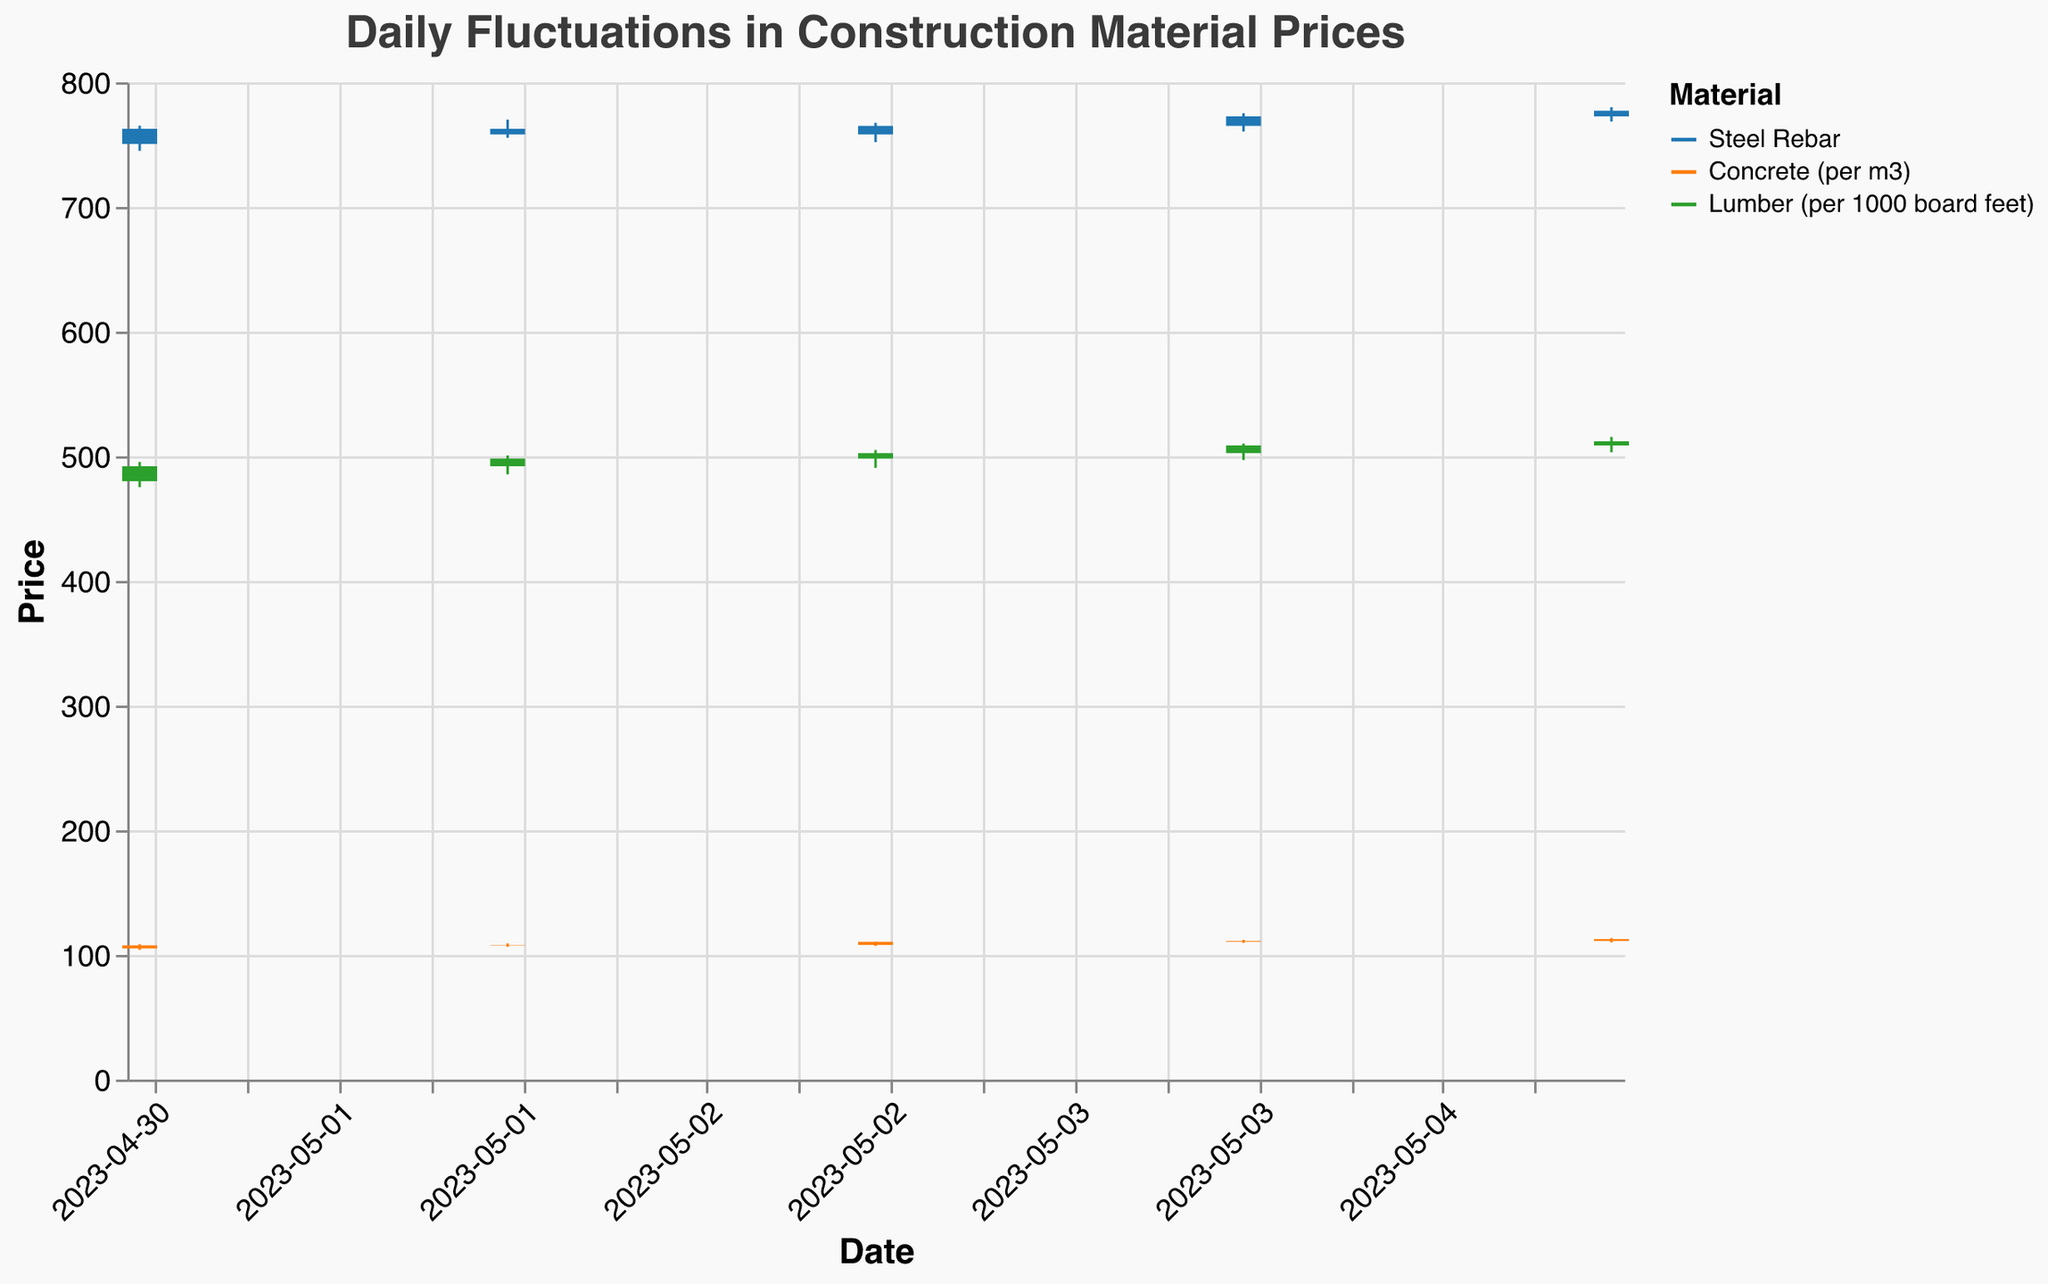what does the plot title indicate? The title of the plot is "Daily Fluctuations in Construction Material Prices," which indicates that the plot shows how the prices of different construction materials fluctuate on a daily basis.
Answer: Daily Fluctuations in Construction Material Prices how many types of materials are being compared? The color legend indicates three different colors, each representing a different construction material: Steel Rebar, Concrete (per m3), and Lumber (per 1000 board feet).
Answer: 3 on which date did Steel Rebar have the lowest price? Referring to the low points on the vertical rules for Steel Rebar, the lowest price was on May 1st, with a low of 745.00.
Answer: 2023-05-01 what was the opening price of Lumber on May 4th? By referencing the data point for Lumber on May 4th, we find that the opening price was 502.50.
Answer: 502.50 which material showed the highest closing price on May 3rd? Among the closing prices on May 3rd, Concrete (per m3) had the highest closing price of 110.50.
Answer: Concrete (per m3) what's the range of Steel Rebar prices on May 5th? For May 5th, Steel Rebar's high and low prices were 780.00 and 768.50 respectively. The range is 780.00 - 768.50 = 11.50.
Answer: 11.50 did Concrete's price increase or decrease from May 4th to May 5th? Concrete's closing price on May 4th was 111.25, and on May 5th it was 112.75. Since 112.75 > 111.25, the price increased.
Answer: increased compared to Lumber, how much did Steel Rebar's closing price increase on May 3rd? Steel Rebar's closing price on May 3rd was 765.00 while Lumber's closing price was 502.50. The increase is 765.00 - 502.50 = 262.50.
Answer: 262.50 which material had the most stable prices throughout the observed period? By considering the data range and fluctuations, Concrete had the smallest variations in its prices every day, making it the most stable material.
Answer: Concrete (per m3) based on the last recorded date, which material closed at a higher price, Steel Rebar or Lumber? On May 5th, the closing price for Steel Rebar was 777.25, and for Lumber, it was 512.00. Therefore, Steel Rebar closed at a higher price.
Answer: Steel Rebar 